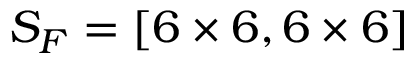<formula> <loc_0><loc_0><loc_500><loc_500>S _ { F } = [ 6 \times 6 , 6 \times 6 ]</formula> 